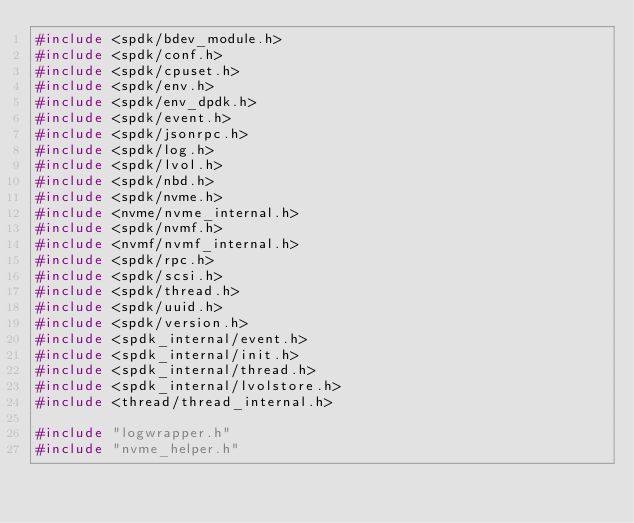Convert code to text. <code><loc_0><loc_0><loc_500><loc_500><_C_>#include <spdk/bdev_module.h>
#include <spdk/conf.h>
#include <spdk/cpuset.h>
#include <spdk/env.h>
#include <spdk/env_dpdk.h>
#include <spdk/event.h>
#include <spdk/jsonrpc.h>
#include <spdk/log.h>
#include <spdk/lvol.h>
#include <spdk/nbd.h>
#include <spdk/nvme.h>
#include <nvme/nvme_internal.h>
#include <spdk/nvmf.h>
#include <nvmf/nvmf_internal.h>
#include <spdk/rpc.h>
#include <spdk/scsi.h>
#include <spdk/thread.h>
#include <spdk/uuid.h>
#include <spdk/version.h>
#include <spdk_internal/event.h>
#include <spdk_internal/init.h>
#include <spdk_internal/thread.h>
#include <spdk_internal/lvolstore.h>
#include <thread/thread_internal.h>

#include "logwrapper.h"
#include "nvme_helper.h"
</code> 